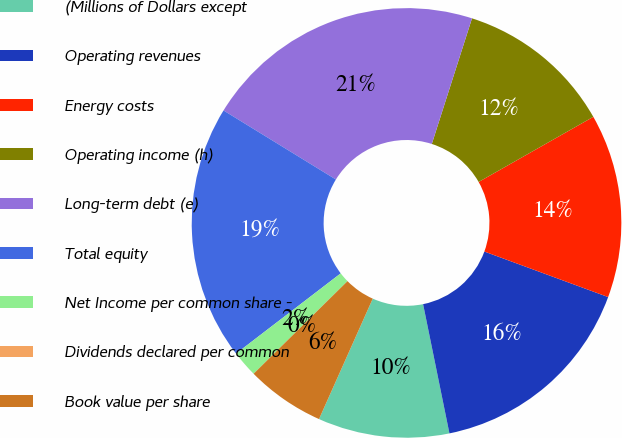Convert chart to OTSL. <chart><loc_0><loc_0><loc_500><loc_500><pie_chart><fcel>(Millions of Dollars except<fcel>Operating revenues<fcel>Energy costs<fcel>Operating income (h)<fcel>Long-term debt (e)<fcel>Total equity<fcel>Net Income per common share -<fcel>Dividends declared per common<fcel>Book value per share<nl><fcel>9.88%<fcel>16.19%<fcel>13.83%<fcel>11.85%<fcel>21.16%<fcel>19.18%<fcel>1.98%<fcel>0.0%<fcel>5.93%<nl></chart> 